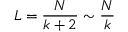<formula> <loc_0><loc_0><loc_500><loc_500>L = \frac { N } { k + 2 } \sim \frac { N } { k }</formula> 